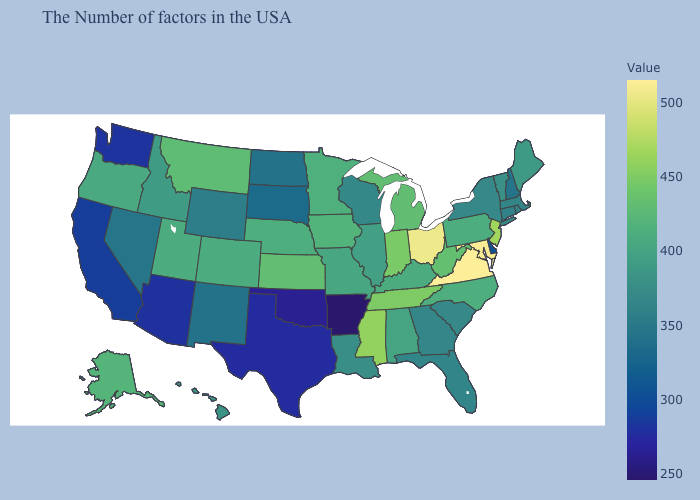Which states have the lowest value in the Northeast?
Write a very short answer. New Hampshire. Does Virginia have the highest value in the USA?
Keep it brief. Yes. Which states have the lowest value in the Northeast?
Write a very short answer. New Hampshire. Does Arizona have a higher value than Louisiana?
Answer briefly. No. 